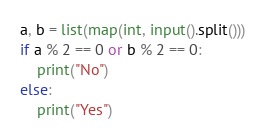<code> <loc_0><loc_0><loc_500><loc_500><_Python_>a, b = list(map(int, input().split()))
if a % 2 == 0 or b % 2 == 0:
    print("No")
else:
    print("Yes")
</code> 